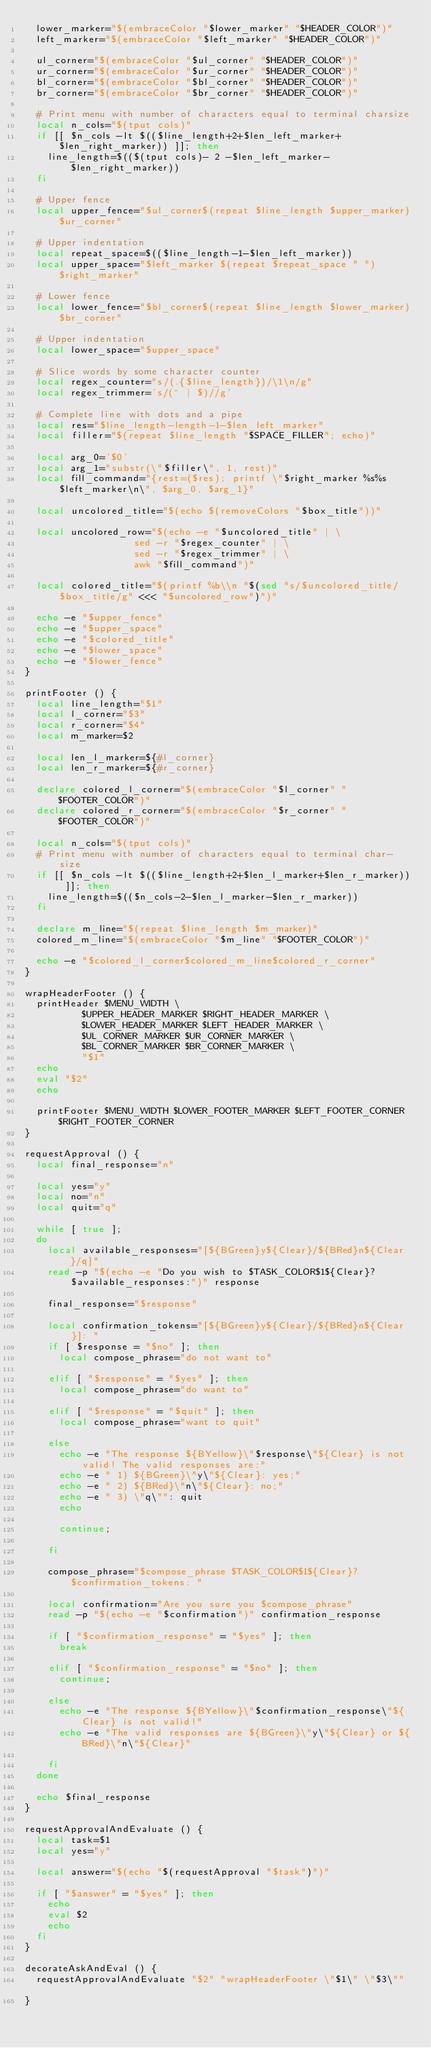Convert code to text. <code><loc_0><loc_0><loc_500><loc_500><_Bash_>	lower_marker="$(embraceColor "$lower_marker" "$HEADER_COLOR")"
	left_marker="$(embraceColor "$left_marker" "$HEADER_COLOR")"
	
	ul_corner="$(embraceColor "$ul_corner" "$HEADER_COLOR")" 
	ur_corner="$(embraceColor "$ur_corner" "$HEADER_COLOR")"
	bl_corner="$(embraceColor "$bl_corner" "$HEADER_COLOR")"
	br_corner="$(embraceColor "$br_corner" "$HEADER_COLOR")"
	
	# Print menu with number of characters equal to terminal charsize 
	local n_cols="$(tput cols)" 
	if [[ $n_cols -lt $(($line_length+2+$len_left_marker+ $len_right_marker)) ]]; then
		line_length=$(($(tput cols)- 2 -$len_left_marker-$len_right_marker))
	fi

	# Upper fence
	local upper_fence="$ul_corner$(repeat $line_length $upper_marker)$ur_corner"
	
	# Upper indentation
	local repeat_space=$(($line_length-1-$len_left_marker))
	local upper_space="$left_marker $(repeat $repeat_space " ") $right_marker"
	
	# Lower fence
	local lower_fence="$bl_corner$(repeat $line_length $lower_marker)$br_corner"

	# Upper indentation
	local lower_space="$upper_space"

	# Slice words by some character counter
	local regex_counter="s/(.{$line_length})/\1\n/g"
	local regex_trimmer='s/(^ | $)//g'

	# Complete line with dots and a pipe
	local res="$line_length-length-1-$len_left_marker"
	local filler="$(repeat $line_length "$SPACE_FILLER"; echo)"
	
	local arg_0='$0'
	local arg_1="substr(\"$filler\", 1, rest)"
	local fill_command="{rest=($res); printf \"$right_marker %s%s $left_marker\n\", $arg_0, $arg_1}"

	local uncolored_title="$(echo $(removeColors "$box_title"))"
	
	local uncolored_row="$(echo -e "$uncolored_title" | \
					   	     sed -r "$regex_counter" | \
					   	     sed -r "$regex_trimmer" | \
					   	     awk "$fill_command")"
	
	local colored_title="$(printf %b\\n "$(sed "s/$uncolored_title/$box_title/g" <<< "$uncolored_row")")"

	echo -e "$upper_fence"
	echo -e "$upper_space" 
	echo -e "$colored_title"
	echo -e "$lower_space"
	echo -e "$lower_fence"
}

printFooter () {
	local line_length="$1"
	local l_corner="$3"
	local r_corner="$4"
	local m_marker=$2

	local len_l_marker=${#l_corner}
	local len_r_marker=${#r_corner}

	declare colored_l_corner="$(embraceColor "$l_corner" "$FOOTER_COLOR")"
	declare colored_r_corner="$(embraceColor "$r_corner" "$FOOTER_COLOR")"

	local n_cols="$(tput cols)"
	# Print menu with number of characters equal to terminal char-size  
	if [[ $n_cols -lt $(($line_length+2+$len_l_marker+$len_r_marker)) ]]; then
		line_length=$(($n_cols-2-$len_l_marker-$len_r_marker))
	fi

	declare m_line="$(repeat $line_length $m_marker)"
	colored_m_line="$(embraceColor "$m_line" "$FOOTER_COLOR")"

	echo -e "$colored_l_corner$colored_m_line$colored_r_corner"
}

wrapHeaderFooter () {
	printHeader $MENU_WIDTH \
			 		$UPPER_HEADER_MARKER $RIGHT_HEADER_MARKER \
				 	$LOWER_HEADER_MARKER $LEFT_HEADER_MARKER \
				 	$UL_CORNER_MARKER $UR_CORNER_MARKER \
				 	$BL_CORNER_MARKER $BR_CORNER_MARKER \
				 	"$1"
	echo 
	eval "$2"
	echo 

	printFooter $MENU_WIDTH $LOWER_FOOTER_MARKER $LEFT_FOOTER_CORNER $RIGHT_FOOTER_CORNER	
}

requestApproval () {
	local final_response="n"

	local yes="y"
	local no="n"
	local quit="q"

	while [ true ];
	do
		local available_responses="[${BGreen}y${Clear}/${BRed}n${Clear}/q]"
		read -p "$(echo -e "Do you wish to $TASK_COLOR$1${Clear}? $available_responses:")" response 

		final_response="$response"

		local confirmation_tokens="[${BGreen}y${Clear}/${BRed}n${Clear}]: "
		if [ $response = "$no" ]; then
			local compose_phrase="do not want to"

		elif [ "$response" = "$yes" ]; then
			local compose_phrase="do want to"

		elif [ "$response" = "$quit" ]; then
			local compose_phrase="want to quit"
		
		else
			echo -e "The response ${BYellow}\"$response\"${Clear} is not valid! The valid responses are:" 
			echo -e " 1) ${BGreen}\"y\"${Clear}: yes;"
			echo -e " 2) ${BRed}\"n\"${Clear}: no;"
			echo -e " 3) \"q\"": quit
			echo 

			continue;			

		fi

		compose_phrase="$compose_phrase $TASK_COLOR$1${Clear}? $confirmation_tokens: "

		local confirmation="Are you sure you $compose_phrase"
		read -p "$(echo -e "$confirmation")" confirmation_response

		if [ "$confirmation_response" = "$yes" ]; then
			break

		elif [ "$confirmation_response" = "$no" ]; then
			continue;

		else
			echo -e "The response ${BYellow}\"$confirmation_response\"${Clear} is not valid!" 
			echo -e "The valid responses are ${BGreen}\"y\"${Clear} or ${BRed}\"n\"${Clear}"
		
		fi
	done

	echo $final_response
}

requestApprovalAndEvaluate () {
	local task=$1
	local yes="y"

	local answer="$(echo "$(requestApproval "$task")")"

	if [ "$answer" = "$yes" ]; then
		echo 
		eval $2
		echo 
	fi
}

decorateAskAndEval () {
	requestApprovalAndEvaluate "$2" "wrapHeaderFooter \"$1\" \"$3\""	
}</code> 